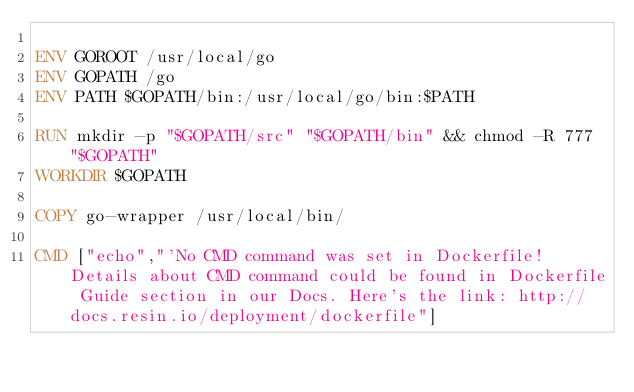<code> <loc_0><loc_0><loc_500><loc_500><_Dockerfile_>
ENV GOROOT /usr/local/go
ENV GOPATH /go
ENV PATH $GOPATH/bin:/usr/local/go/bin:$PATH

RUN mkdir -p "$GOPATH/src" "$GOPATH/bin" && chmod -R 777 "$GOPATH"
WORKDIR $GOPATH

COPY go-wrapper /usr/local/bin/

CMD ["echo","'No CMD command was set in Dockerfile! Details about CMD command could be found in Dockerfile Guide section in our Docs. Here's the link: http://docs.resin.io/deployment/dockerfile"]
</code> 